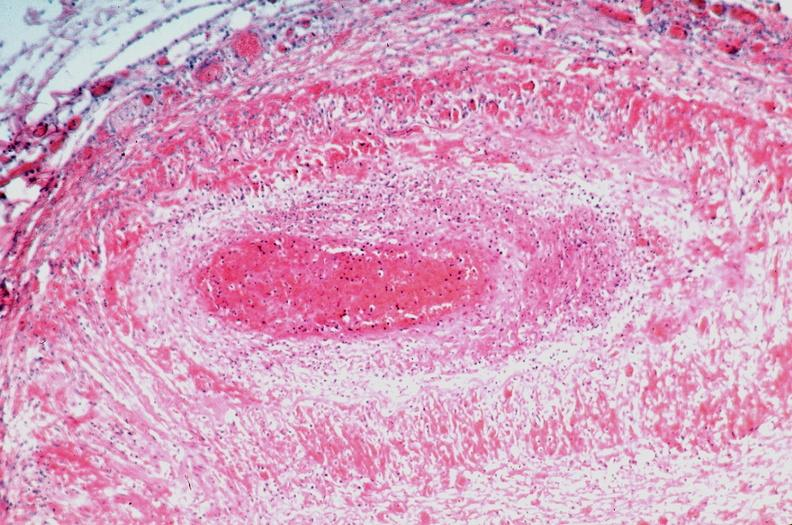does myocardium show vasculitis, polyarteritis nodosa?
Answer the question using a single word or phrase. No 